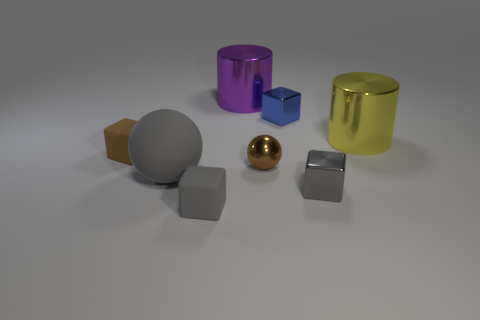The tiny block that is behind the large gray thing and to the right of the large gray sphere is made of what material?
Your answer should be compact. Metal. Is there a big ball that is in front of the large cylinder that is behind the yellow shiny thing?
Offer a terse response. Yes. Do the large purple cylinder and the yellow cylinder have the same material?
Keep it short and to the point. Yes. There is a big object that is right of the big gray sphere and to the left of the tiny blue shiny thing; what is its shape?
Your response must be concise. Cylinder. There is a shiny cube in front of the big shiny cylinder right of the small sphere; how big is it?
Give a very brief answer. Small. How many big yellow shiny objects are the same shape as the big purple object?
Provide a succinct answer. 1. Is the tiny ball the same color as the big rubber ball?
Your answer should be compact. No. Is there any other thing that is the same shape as the large matte thing?
Your answer should be very brief. Yes. Is there a large cylinder that has the same color as the tiny shiny sphere?
Your answer should be very brief. No. Is the tiny thing that is behind the yellow metal thing made of the same material as the sphere left of the large purple cylinder?
Provide a short and direct response. No. 